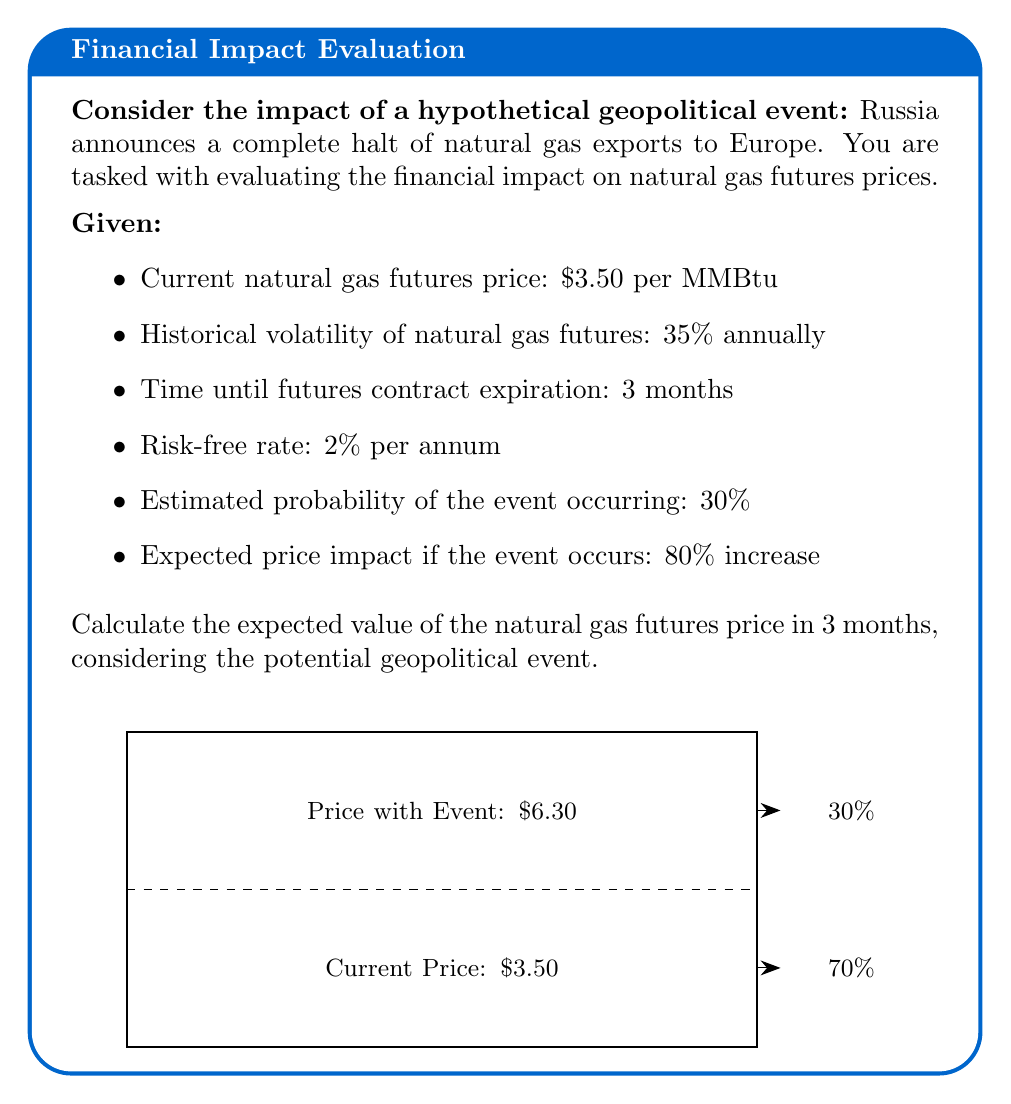What is the answer to this math problem? Let's approach this step-by-step:

1) First, we need to calculate the expected price if the event occurs:
   $P_{event} = $3.50 * (1 + 0.80) = $6.30$ per MMBtu

2) Now, we can set up the expected value calculation:
   $E[P] = P_{event} * P(event) + P_{current} * (1 - P(event))$
   where $P(event)$ is the probability of the event occurring

3) Plugging in the values:
   $E[P] = $6.30 * 0.30 + $3.50 * (1 - 0.30)$

4) Calculating:
   $E[P] = $1.89 + $2.45 = $4.34$ per MMBtu

5) However, we need to consider the time value of money. We can use the risk-free rate to discount this expected value back to present:

   $PV = \frac{E[P]}{(1 + r)^t}$

   Where $r$ is the annual risk-free rate and $t$ is the time in years.

6) Plugging in the values:
   $PV = \frac{$4.34}{(1 + 0.02)^{3/12}} = \frac{$4.34}{1.0049} = $4.32$ per MMBtu

Therefore, the expected value of the natural gas futures price in 3 months, considering the potential geopolitical event, is $4.32 per MMBtu.
Answer: $4.32 per MMBtu 